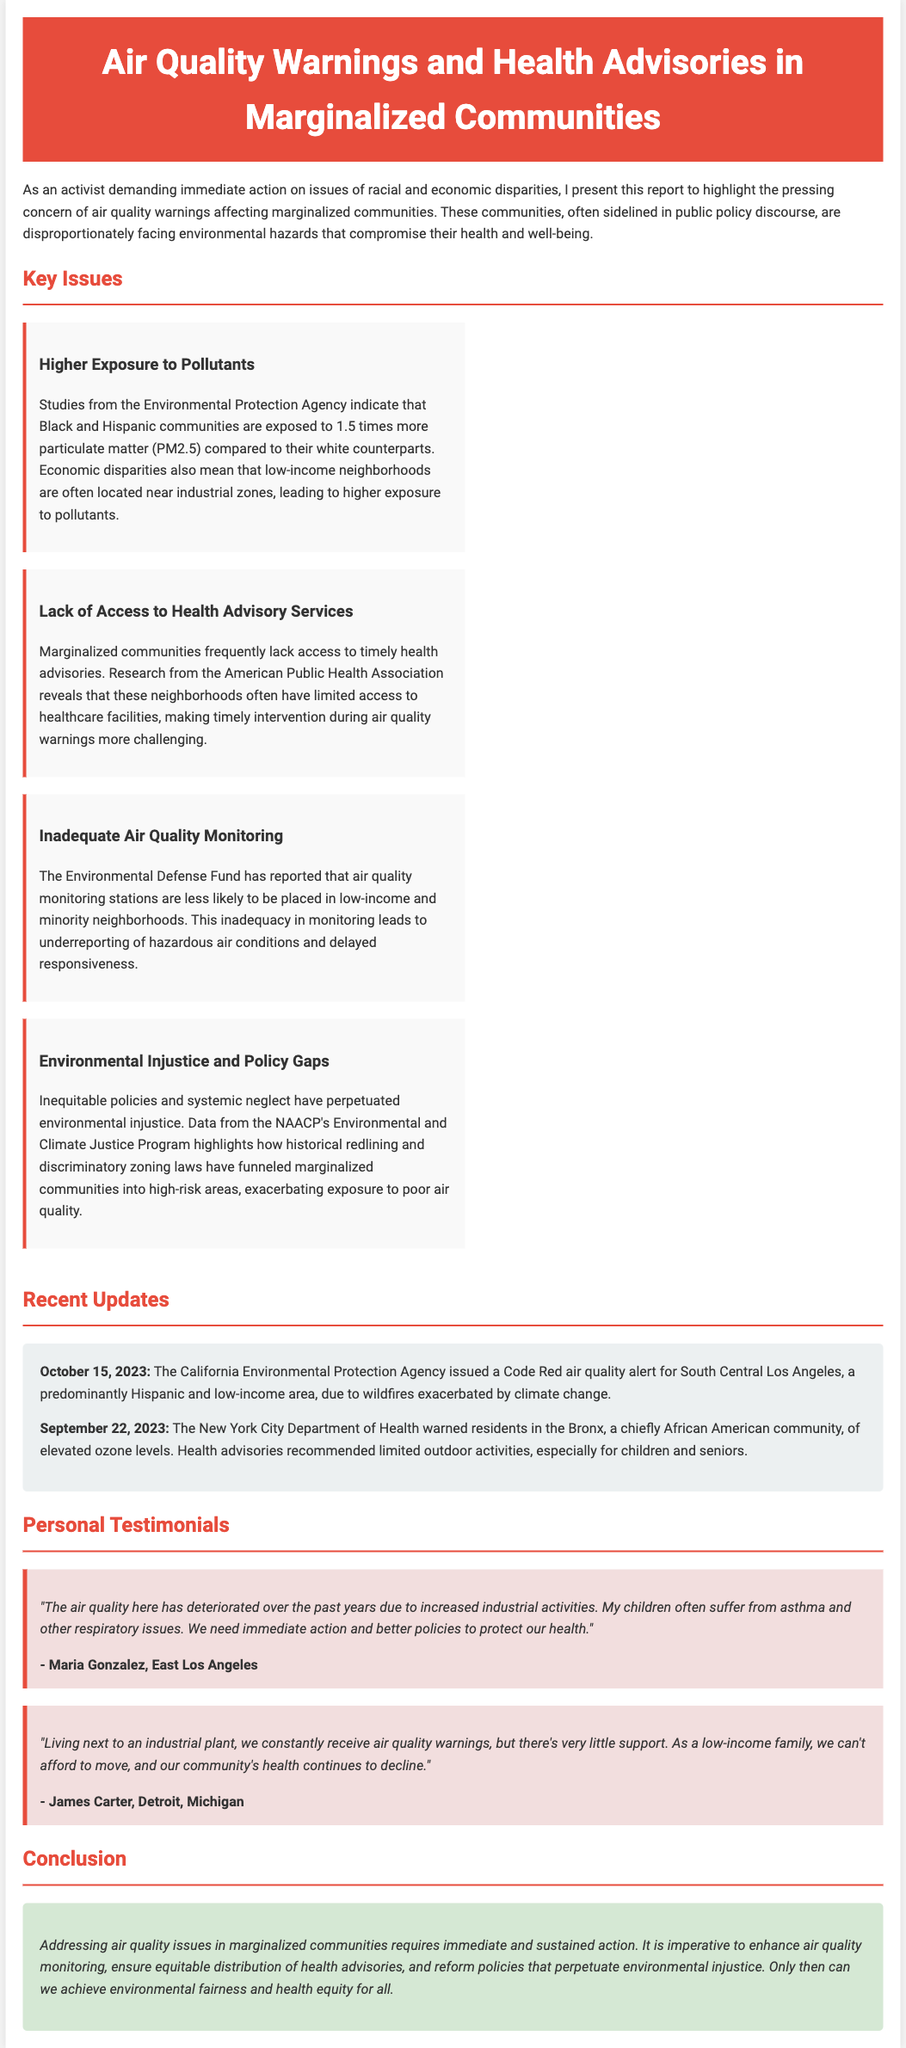What is the title of the report? The title of the report is stated in the header section.
Answer: Air Quality Warnings and Health Advisories in Marginalized Communities Which communities are highlighted as being disproportionately affected by air quality issues? The document specifically mentions Black and Hispanic communities as being disproportionately affected.
Answer: Black and Hispanic communities What percentage more particulate matter are marginalized communities exposed to compared to white communities? The document provides a comparison of exposure levels to particulate matter.
Answer: 1.5 times When was the Code Red air quality alert issued? The date of the issuance for the Code Red alert is specified in the updates section.
Answer: October 15, 2023 What does the lack of access to health advisory services lead to in marginalized communities? The document describes the impact of limited access to healthcare facilities in relation to air quality alerts.
Answer: Timely intervention challenges Which community received a warning about elevated ozone levels? The document mentions a specific community that received a health advisory.
Answer: Bronx What is one of the suggested actions to address air quality issues? The conclusion section provides a potential action to improve air quality in marginalized communities.
Answer: Enhance air quality monitoring Who reported that air quality monitoring stations are less likely to be placed in low-income neighborhoods? The document attributes this finding to a specific organization that conducted a study.
Answer: Environmental Defense Fund What health issues did Maria Gonzalez mention in her testimonial? The testimonial in the personal section highlights specific health problems faced by Maria's children.
Answer: Asthma and respiratory issues 